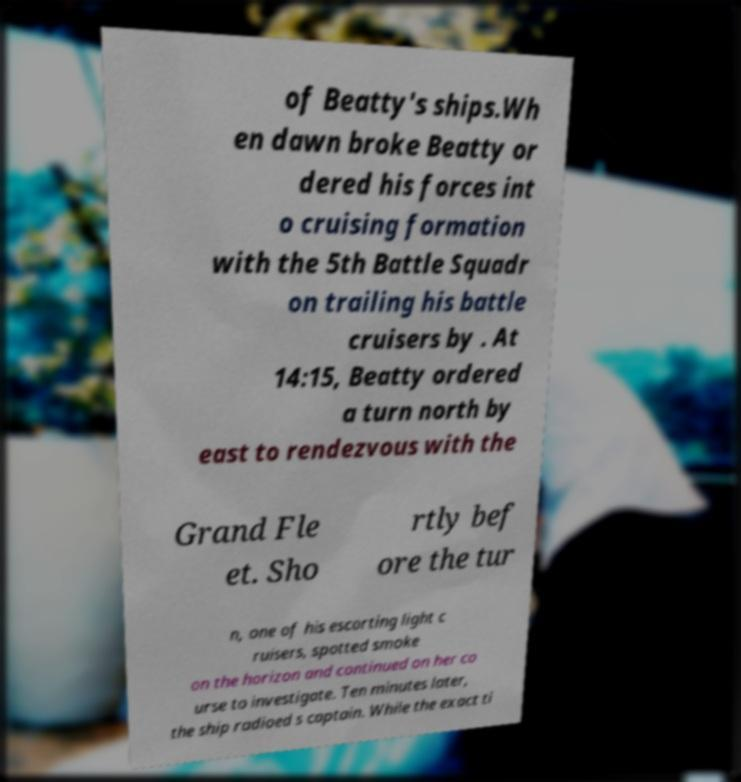There's text embedded in this image that I need extracted. Can you transcribe it verbatim? of Beatty's ships.Wh en dawn broke Beatty or dered his forces int o cruising formation with the 5th Battle Squadr on trailing his battle cruisers by . At 14:15, Beatty ordered a turn north by east to rendezvous with the Grand Fle et. Sho rtly bef ore the tur n, one of his escorting light c ruisers, spotted smoke on the horizon and continued on her co urse to investigate. Ten minutes later, the ship radioed s captain. While the exact ti 